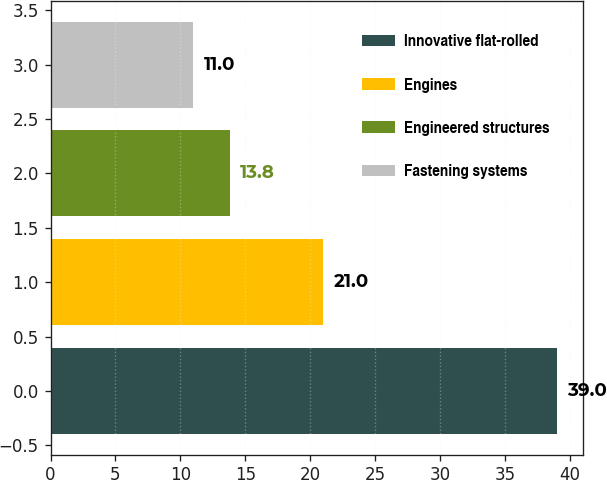<chart> <loc_0><loc_0><loc_500><loc_500><bar_chart><fcel>Innovative flat-rolled<fcel>Engines<fcel>Engineered structures<fcel>Fastening systems<nl><fcel>39<fcel>21<fcel>13.8<fcel>11<nl></chart> 